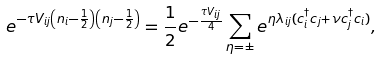Convert formula to latex. <formula><loc_0><loc_0><loc_500><loc_500>e ^ { - \tau V _ { i j } \left ( n _ { i } - \frac { 1 } { 2 } \right ) \left ( n _ { j } - \frac { 1 } { 2 } \right ) } = \frac { 1 } { 2 } e ^ { - \frac { \tau V _ { i j } } { 4 } } \sum _ { \eta = \pm } e ^ { \eta \lambda _ { i j } ( c ^ { \dagger } _ { i } c _ { j } + \nu c ^ { \dagger } _ { j } c _ { i } ) } ,</formula> 